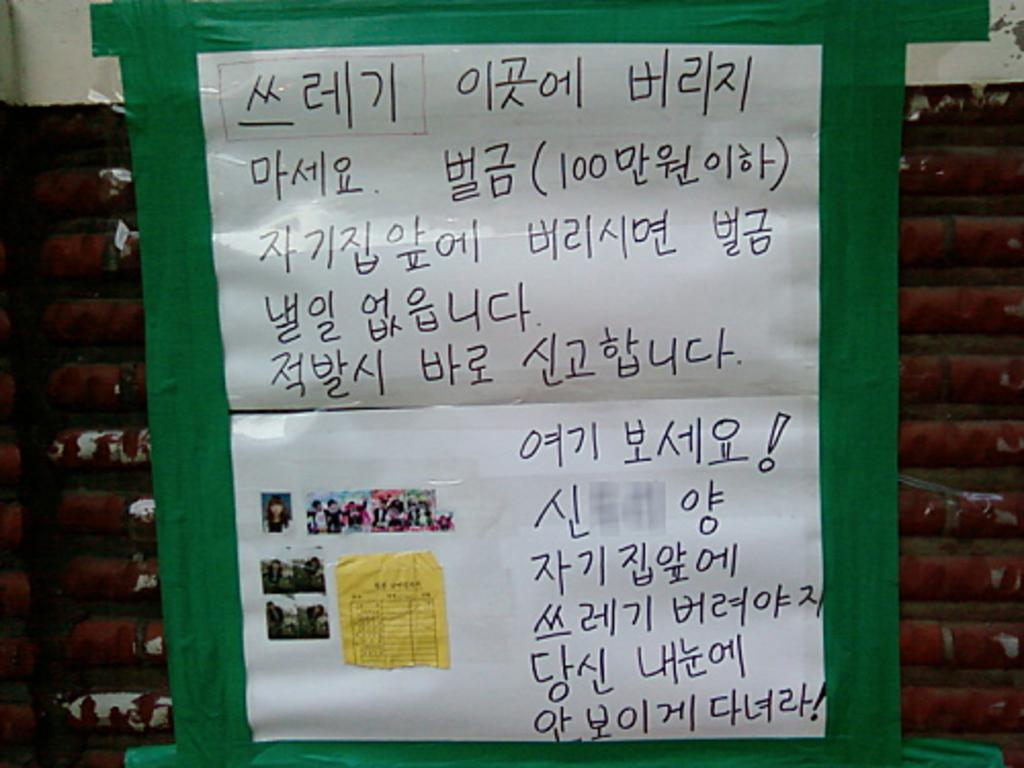What is the main object in the image? There is a poster in the image. What can be seen on the poster? There are people depicted on the poster, and there is text on the poster. What is visible in the background of the image? There is a wall in the background of the image. What time of day is depicted in the image? The time of day is not depicted in the image; it is a static poster with people, text, and a wall in the background. 